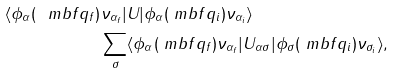Convert formula to latex. <formula><loc_0><loc_0><loc_500><loc_500>\langle \phi _ { \alpha } ( \ m b f { q } _ { f } ) & \nu _ { \alpha _ { f } } | U | \phi _ { \alpha } ( \ m b f { q } _ { i } ) \nu _ { \alpha _ { i } } \rangle \\ & \sum _ { \sigma } \langle \phi _ { \alpha } ( \ m b f { q } _ { f } ) \nu _ { \alpha _ { f } } | U _ { \alpha \sigma } | \phi _ { \sigma } ( \ m b f { q } _ { i } ) \nu _ { \sigma _ { i } } \rangle ,</formula> 